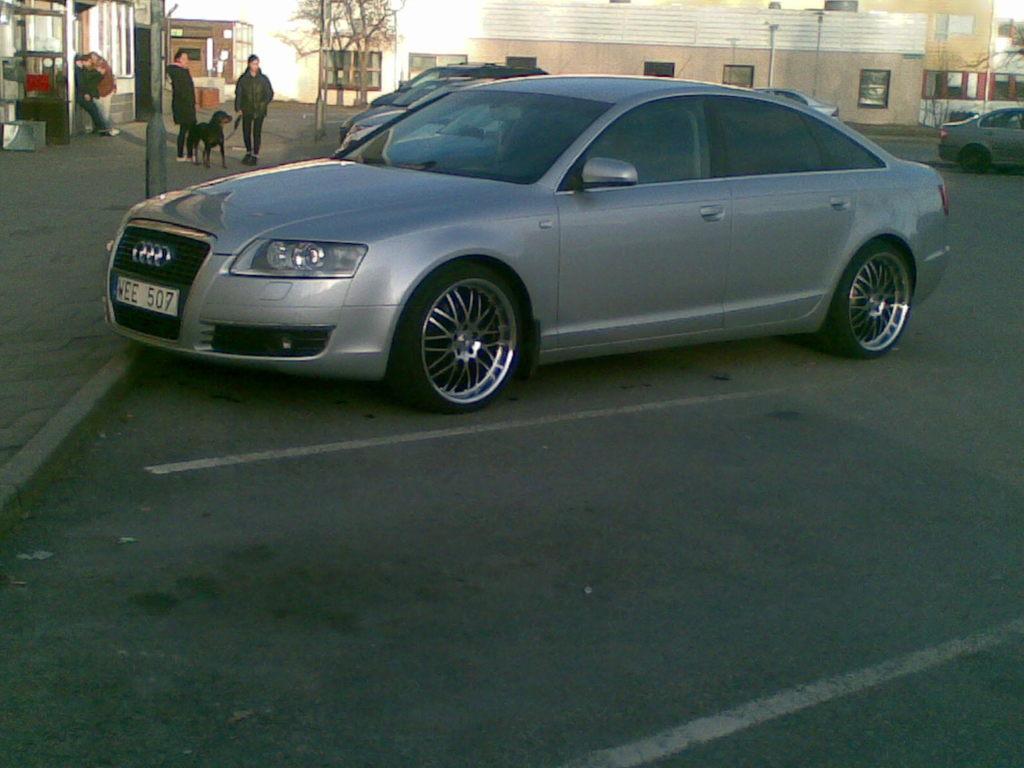How would you summarize this image in a sentence or two? In this picture we can see cars, two people standing, dog on the road and in the background we can see buildings with windows, trees, footpath, some people and some objects. 